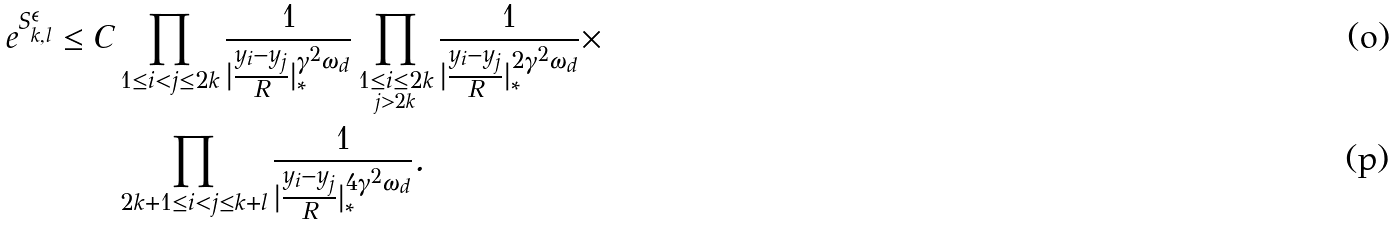<formula> <loc_0><loc_0><loc_500><loc_500>e ^ { S _ { k , l } ^ { \epsilon } } \leq C & \prod _ { 1 \leq i < j \leq 2 k } \frac { 1 } { | \frac { y _ { i } - y _ { j } } { R } | _ { * } ^ { \gamma ^ { 2 } \omega _ { d } } } \prod _ { \underset { j > 2 k } { 1 \leq i \leq 2 k } } \frac { 1 } { | \frac { y _ { i } - y _ { j } } { R } | _ { * } ^ { 2 \gamma ^ { 2 } \omega _ { d } } } \times \\ & \prod _ { 2 k + 1 \leq i < j \leq k + l } \frac { 1 } { | \frac { y _ { i } - y _ { j } } { R } | _ { * } ^ { 4 \gamma ^ { 2 } \omega _ { d } } } .</formula> 